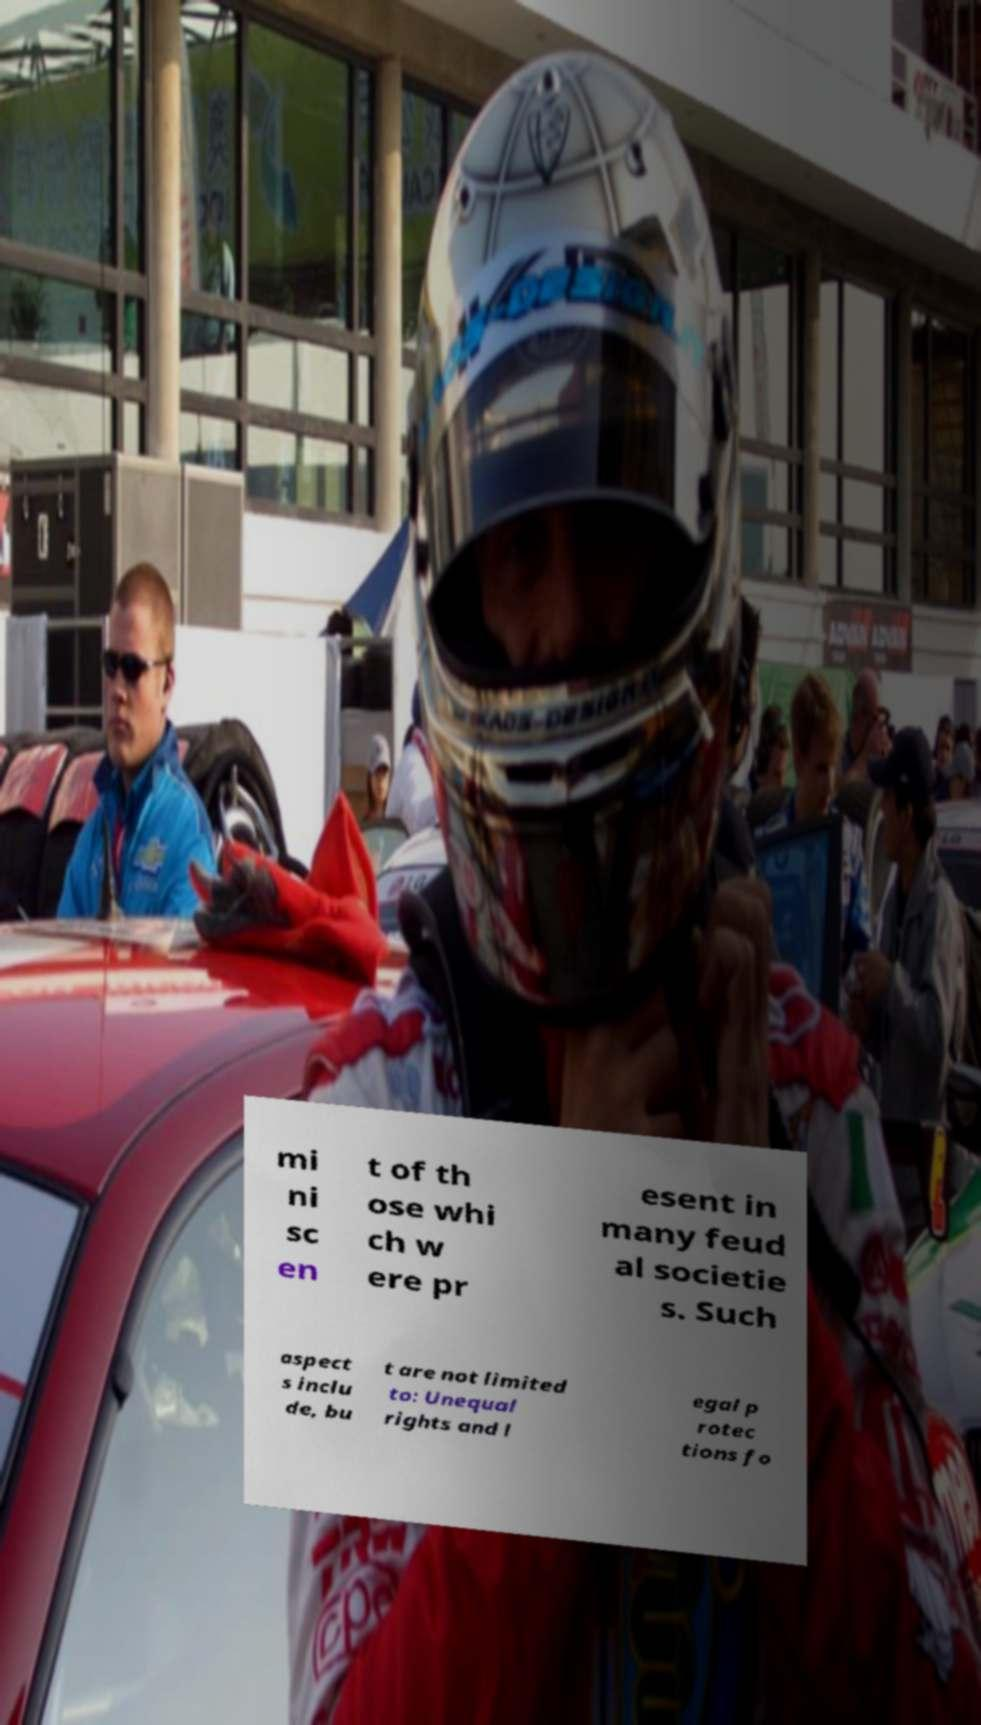Could you extract and type out the text from this image? mi ni sc en t of th ose whi ch w ere pr esent in many feud al societie s. Such aspect s inclu de, bu t are not limited to: Unequal rights and l egal p rotec tions fo 